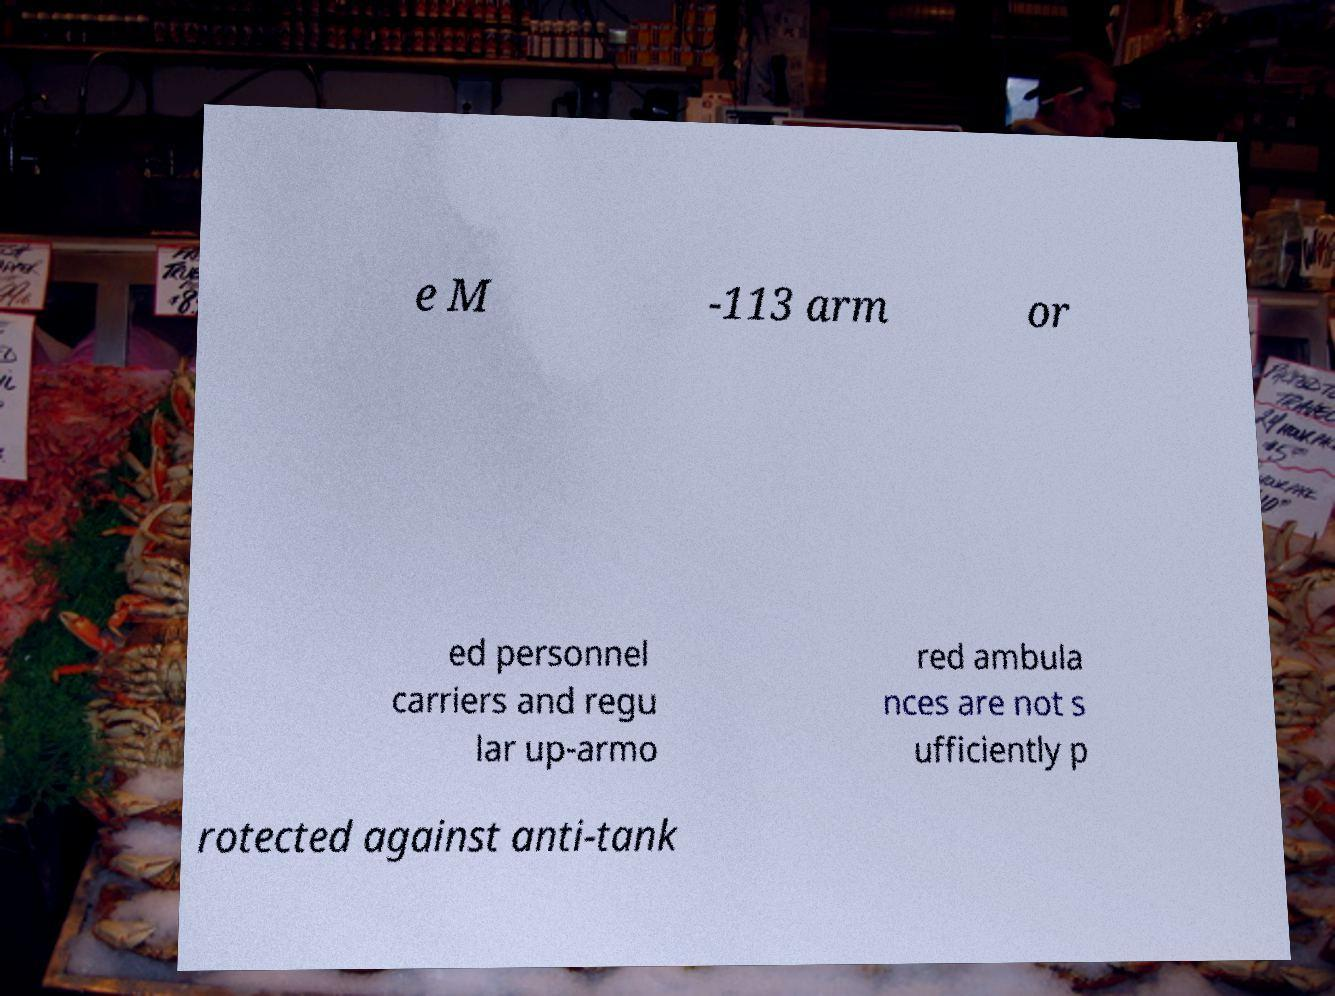Could you assist in decoding the text presented in this image and type it out clearly? e M -113 arm or ed personnel carriers and regu lar up-armo red ambula nces are not s ufficiently p rotected against anti-tank 